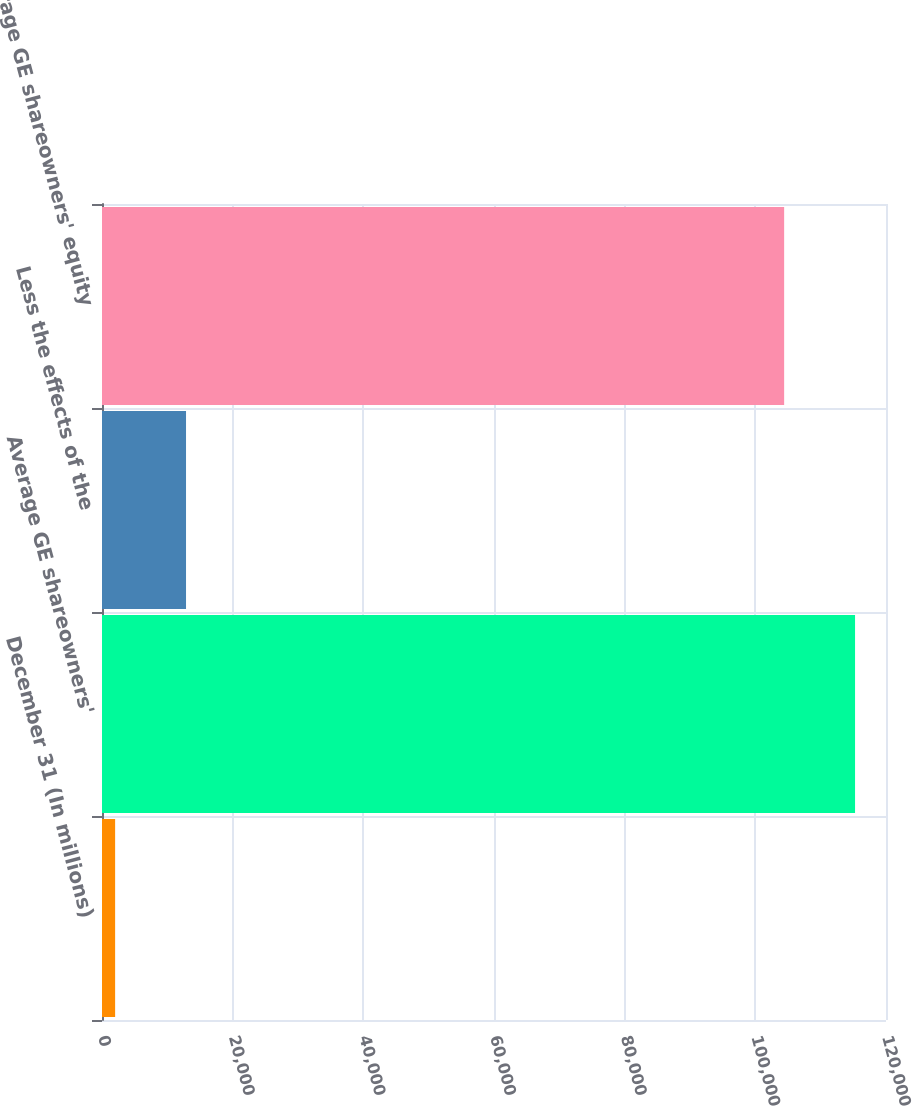Convert chart. <chart><loc_0><loc_0><loc_500><loc_500><bar_chart><fcel>December 31 (In millions)<fcel>Average GE shareowners'<fcel>Less the effects of the<fcel>Average GE shareowners' equity<nl><fcel>2009<fcel>115263<fcel>12861.6<fcel>104410<nl></chart> 